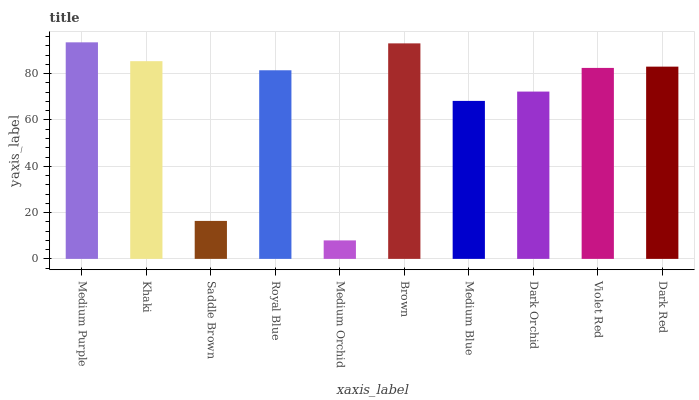Is Medium Orchid the minimum?
Answer yes or no. Yes. Is Medium Purple the maximum?
Answer yes or no. Yes. Is Khaki the minimum?
Answer yes or no. No. Is Khaki the maximum?
Answer yes or no. No. Is Medium Purple greater than Khaki?
Answer yes or no. Yes. Is Khaki less than Medium Purple?
Answer yes or no. Yes. Is Khaki greater than Medium Purple?
Answer yes or no. No. Is Medium Purple less than Khaki?
Answer yes or no. No. Is Violet Red the high median?
Answer yes or no. Yes. Is Royal Blue the low median?
Answer yes or no. Yes. Is Medium Orchid the high median?
Answer yes or no. No. Is Medium Orchid the low median?
Answer yes or no. No. 